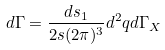<formula> <loc_0><loc_0><loc_500><loc_500>d \Gamma = \frac { d s _ { 1 } } { 2 s ( 2 \pi ) ^ { 3 } } d ^ { 2 } { q } d \Gamma _ { X }</formula> 